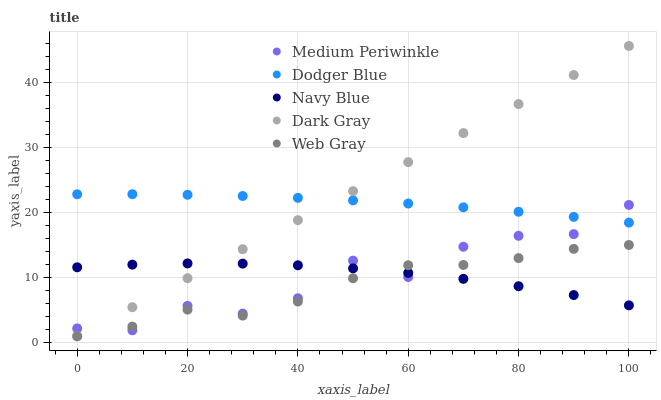Does Web Gray have the minimum area under the curve?
Answer yes or no. Yes. Does Dark Gray have the maximum area under the curve?
Answer yes or no. Yes. Does Dodger Blue have the minimum area under the curve?
Answer yes or no. No. Does Dodger Blue have the maximum area under the curve?
Answer yes or no. No. Is Dark Gray the smoothest?
Answer yes or no. Yes. Is Medium Periwinkle the roughest?
Answer yes or no. Yes. Is Dodger Blue the smoothest?
Answer yes or no. No. Is Dodger Blue the roughest?
Answer yes or no. No. Does Dark Gray have the lowest value?
Answer yes or no. Yes. Does Dodger Blue have the lowest value?
Answer yes or no. No. Does Dark Gray have the highest value?
Answer yes or no. Yes. Does Dodger Blue have the highest value?
Answer yes or no. No. Is Web Gray less than Dodger Blue?
Answer yes or no. Yes. Is Dodger Blue greater than Navy Blue?
Answer yes or no. Yes. Does Dark Gray intersect Navy Blue?
Answer yes or no. Yes. Is Dark Gray less than Navy Blue?
Answer yes or no. No. Is Dark Gray greater than Navy Blue?
Answer yes or no. No. Does Web Gray intersect Dodger Blue?
Answer yes or no. No. 